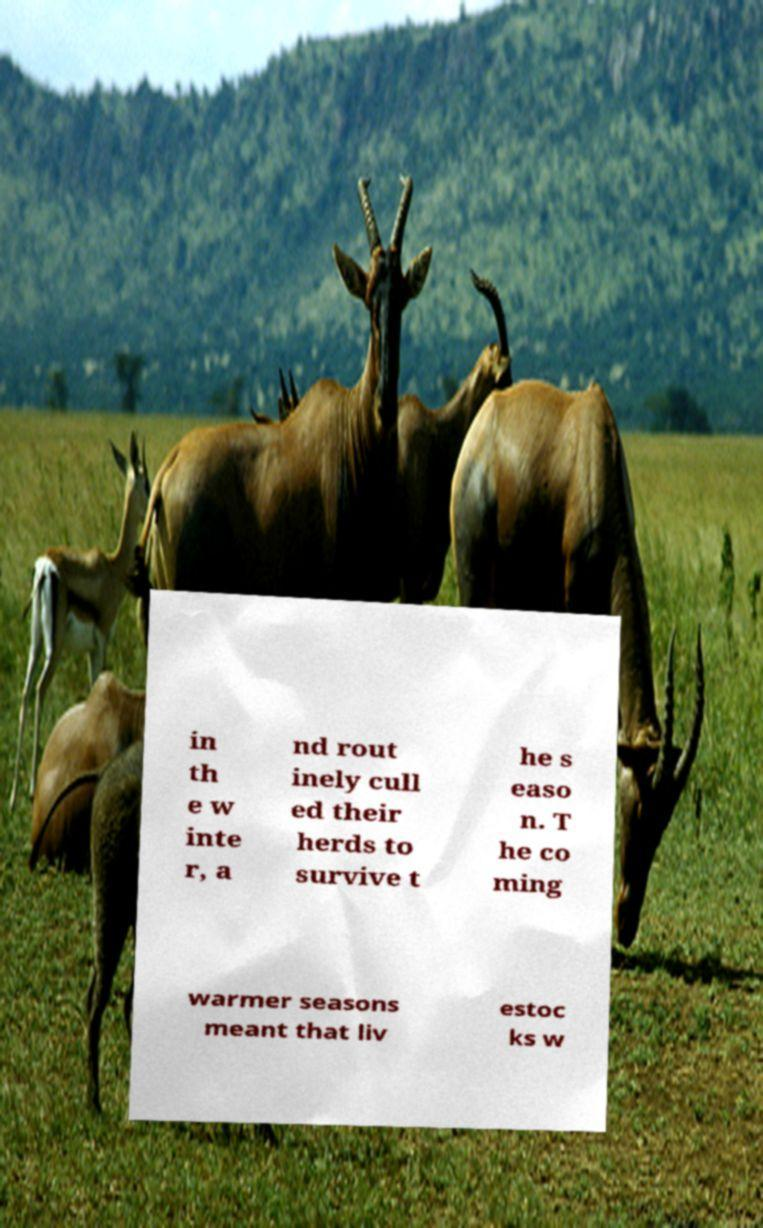Could you extract and type out the text from this image? in th e w inte r, a nd rout inely cull ed their herds to survive t he s easo n. T he co ming warmer seasons meant that liv estoc ks w 